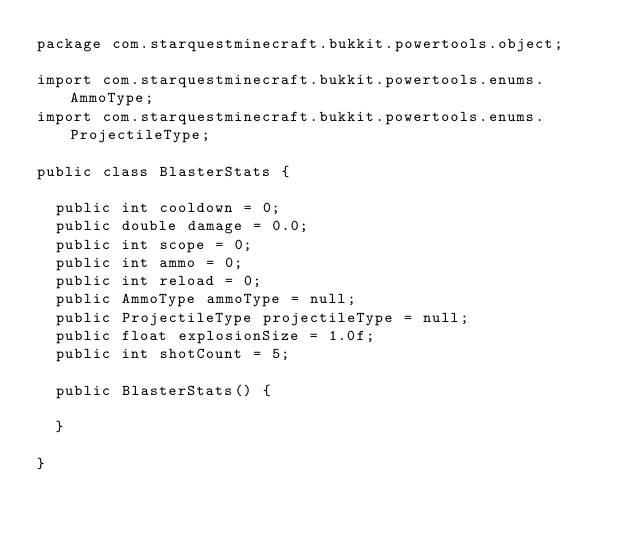Convert code to text. <code><loc_0><loc_0><loc_500><loc_500><_Java_>package com.starquestminecraft.bukkit.powertools.object;

import com.starquestminecraft.bukkit.powertools.enums.AmmoType;
import com.starquestminecraft.bukkit.powertools.enums.ProjectileType;

public class BlasterStats {

	public int cooldown = 0;
	public double damage = 0.0;
	public int scope = 0;
	public int ammo = 0;
	public int reload = 0;
	public AmmoType ammoType = null;
	public ProjectileType projectileType = null;
	public float explosionSize = 1.0f;
	public int shotCount = 5;
	
	public BlasterStats() {
		
	}
	
}
</code> 